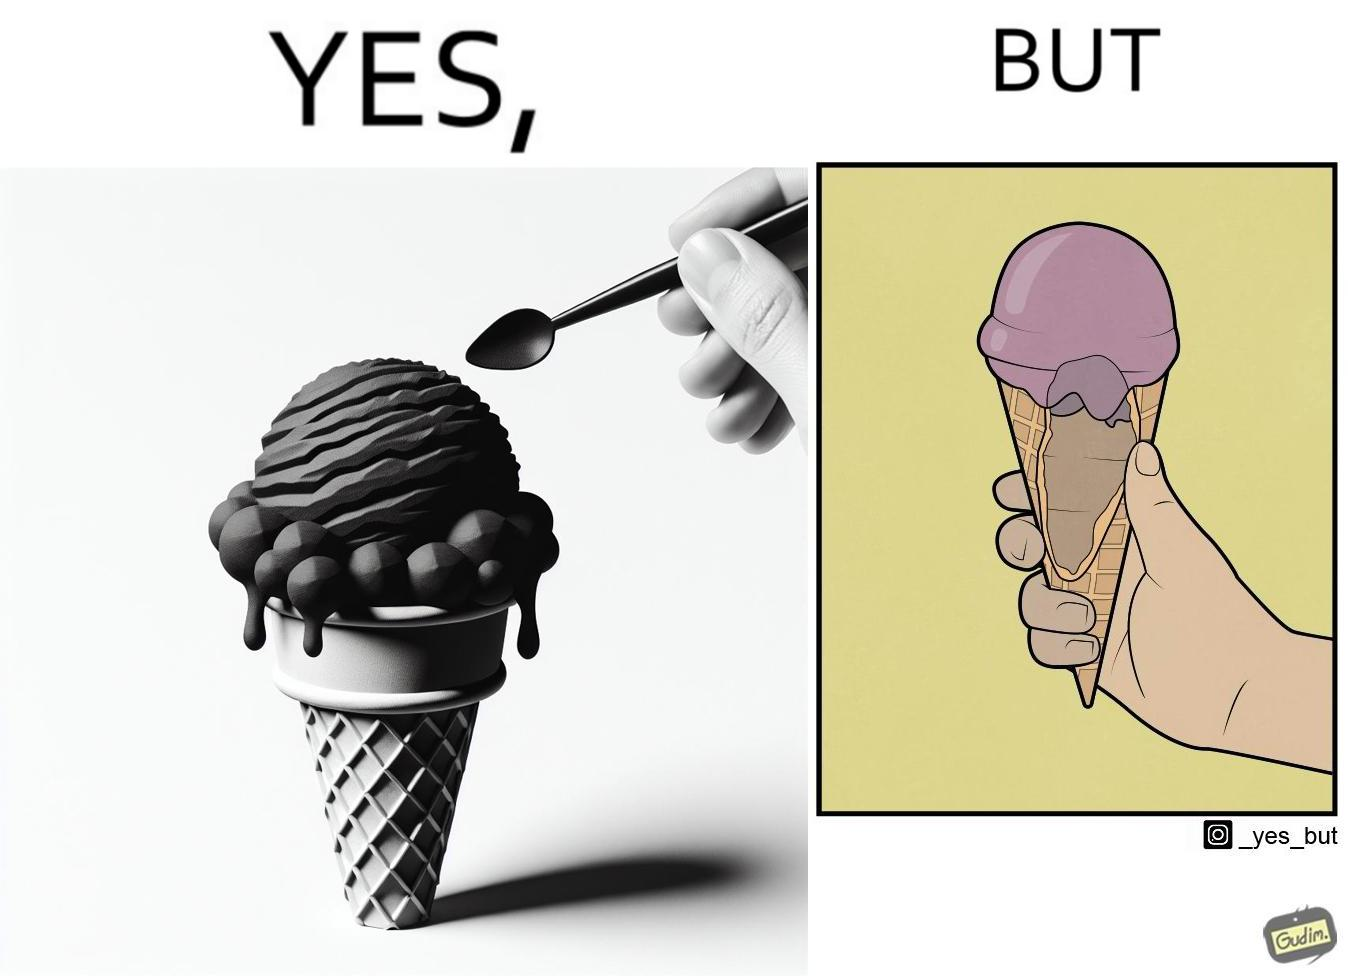Describe what you see in the left and right parts of this image. In the left part of the image: a softy cone filed with ice cream at top and probably melting from the sides because of more quantity than space In the right part of the image: an open section of softy cone showing only a limited softy is filled over the cone and the hollow part of ice cream is empty or vacant 